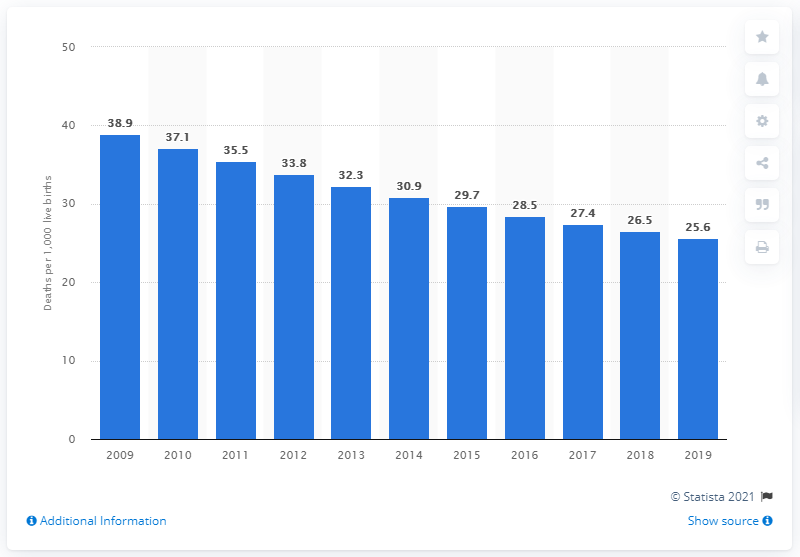List a handful of essential elements in this visual. In 2019, the infant mortality rate in Nepal was 25.6 deaths per 1,000 live births, according to recent data. 